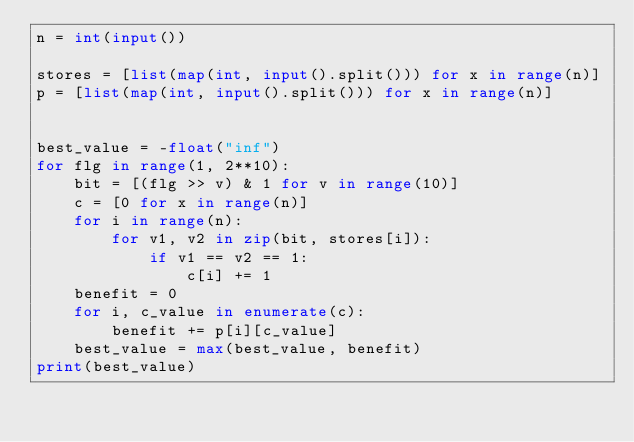<code> <loc_0><loc_0><loc_500><loc_500><_Python_>n = int(input())

stores = [list(map(int, input().split())) for x in range(n)]
p = [list(map(int, input().split())) for x in range(n)]


best_value = -float("inf")
for flg in range(1, 2**10):
    bit = [(flg >> v) & 1 for v in range(10)]
    c = [0 for x in range(n)]
    for i in range(n):
        for v1, v2 in zip(bit, stores[i]):
            if v1 == v2 == 1:
                c[i] += 1
    benefit = 0
    for i, c_value in enumerate(c):
        benefit += p[i][c_value]
    best_value = max(best_value, benefit)
print(best_value)
</code> 